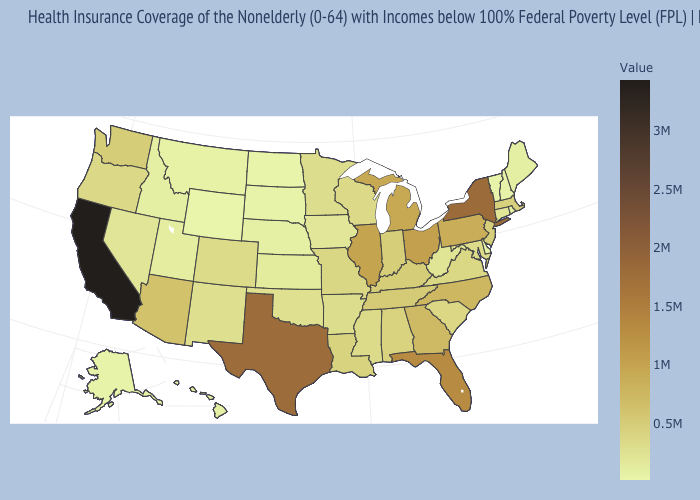Which states hav the highest value in the West?
Give a very brief answer. California. Among the states that border North Dakota , which have the lowest value?
Keep it brief. South Dakota. Among the states that border New Mexico , which have the highest value?
Be succinct. Texas. Which states have the lowest value in the West?
Give a very brief answer. Wyoming. Does California have the highest value in the USA?
Short answer required. Yes. 